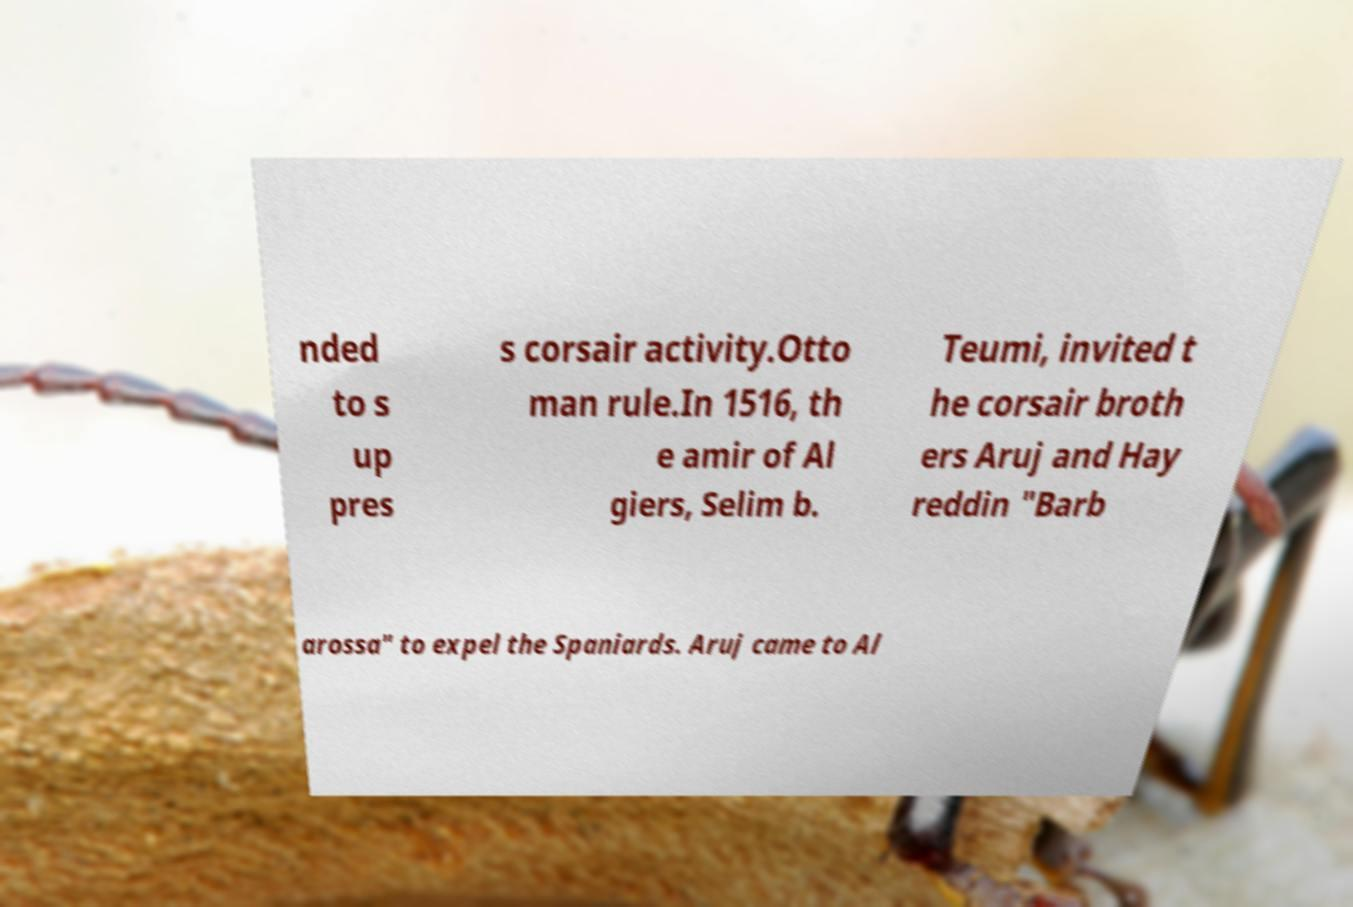What messages or text are displayed in this image? I need them in a readable, typed format. nded to s up pres s corsair activity.Otto man rule.In 1516, th e amir of Al giers, Selim b. Teumi, invited t he corsair broth ers Aruj and Hay reddin "Barb arossa" to expel the Spaniards. Aruj came to Al 